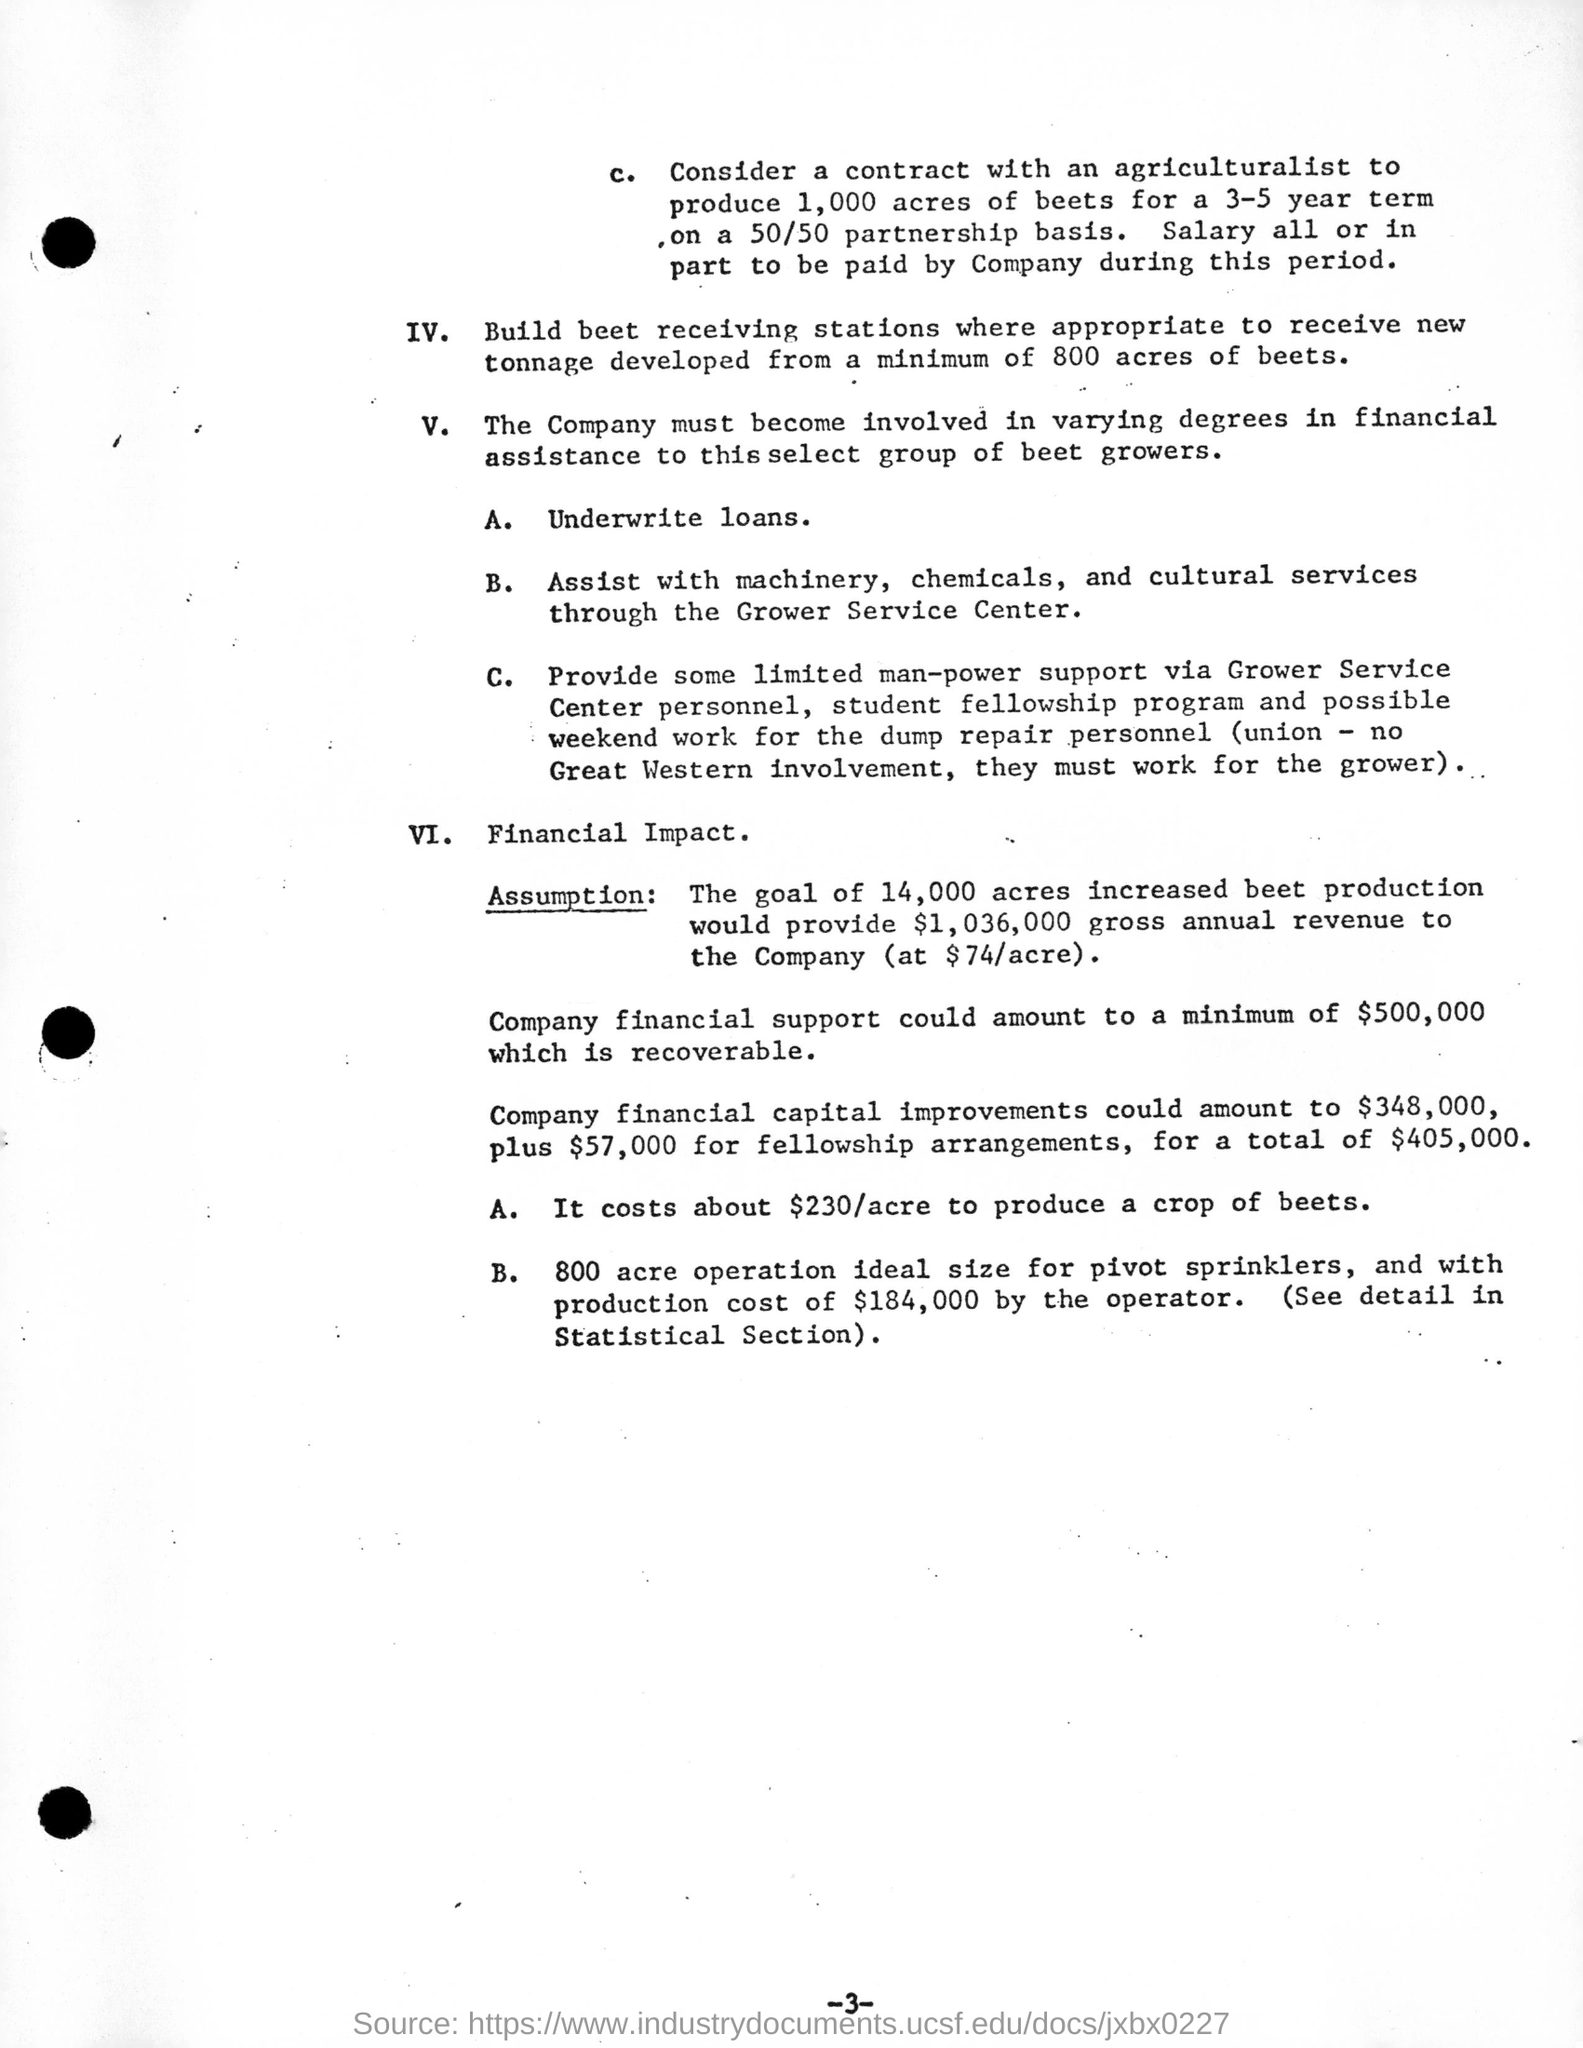Outline some significant characteristics in this image. The page number is 3. 